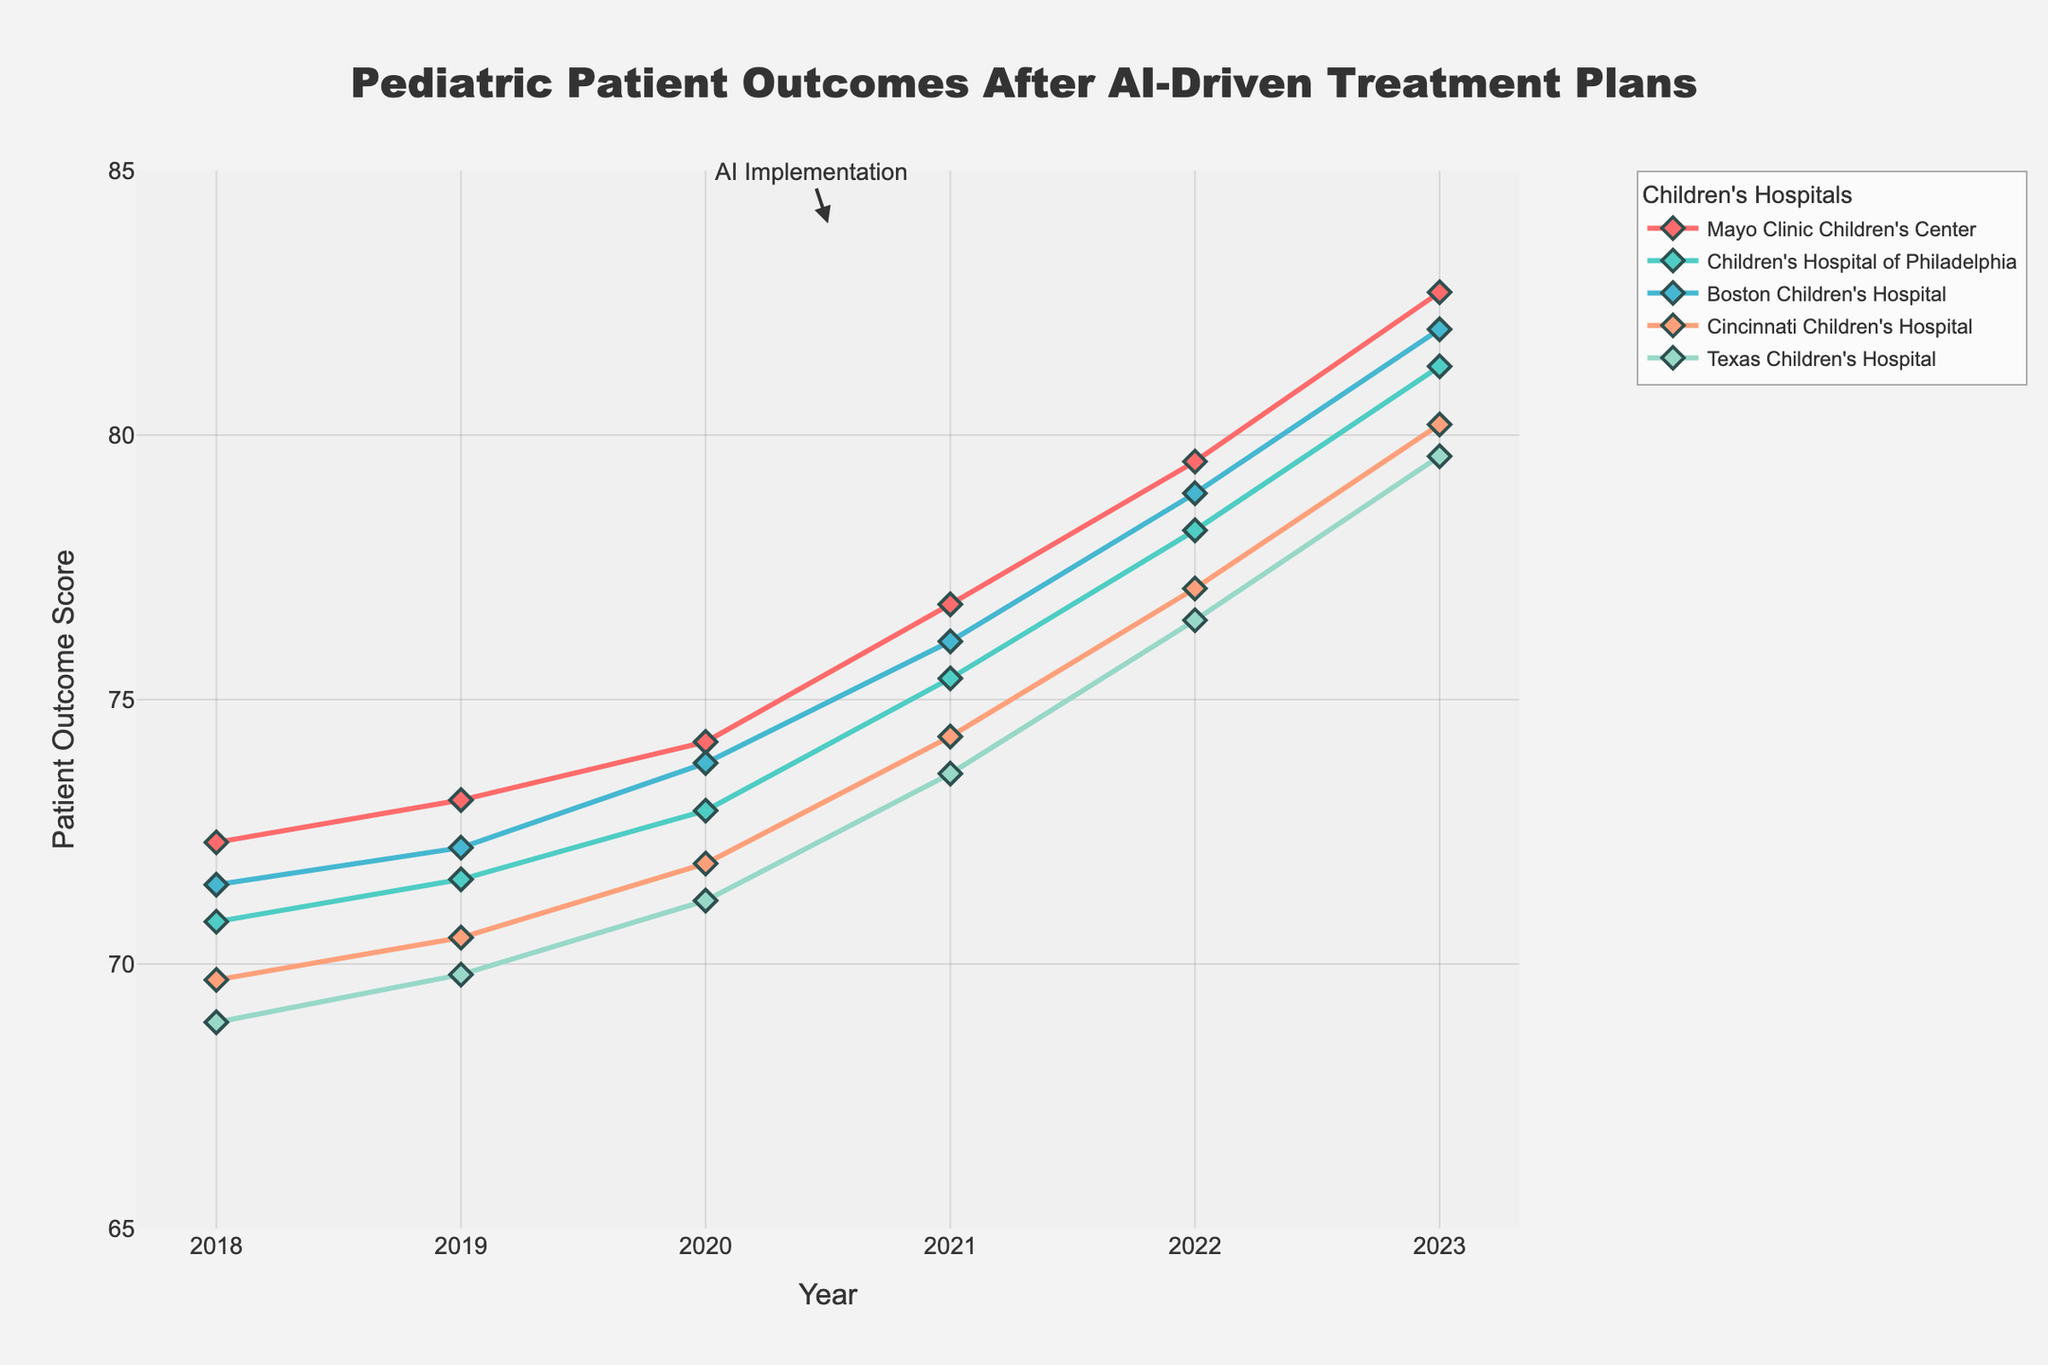What is the overall trend in patient outcome scores from 2018 to 2023 for the hospitals? A step-by-step review of the lines in the plot shows an overall increase in patient outcome scores for all the hospitals. Each line rises year by year until 2023, indicating an improvement.
Answer: Increasing Which hospital had the highest patient outcome score in 2023? By looking at the end of each line in the plot for 2023, the Mayo Clinic Children's Center has the highest outcome score (82.7).
Answer: Mayo Clinic Children's Center In what year did Boston Children's Hospital surpass a patient outcome score of 75? By tracing the line for Boston Children's Hospital, we see that it surpasses 75 in the year 2021.
Answer: 2021 By how many points did Cincinnati Children's Hospital's patient outcome scores increase from 2018 to 2023? To find the increase, subtract the score in 2018 (69.7) from the score in 2023 (80.2). The difference is 80.2 - 69.7 = 10.5 points.
Answer: 10.5 Which hospital showed the greatest improvement in patient outcome scores from 2020 to 2023? By calculating the difference for each hospital between 2020 and 2023 and comparing them, Mayo Clinic Children's Center improved from 74.2 to 82.7, which is an increase of 82.7 - 74.2 = 8.5 points, the largest improvement among the hospitals.
Answer: Mayo Clinic Children's Center How does the trend in patient outcomes for Texas Children's Hospital compare to that of Children's Hospital of Philadelphia from 2018 to 2023? Comparing the lines, both hospitals show an increasing trend. Texas Children's Hospital starts lower but maintains a steady rise similar to Children's Hospital of Philadelphia. Both follow a pattern of improvement, but Children's Hospital of Philadelphia remains constantly higher than Texas Children's Hospital over the years.
Answer: Both increasing, but Children's Hospital of Philadelphia consistently higher What was the average patient outcome score across all hospitals in 2022? By summing the scores for 2022 (79.5, 78.2, 78.9, 77.1, 76.5) and dividing by the number of hospitals (5), the average score is (79.5 + 78.2 + 78.9 + 77.1 + 76.5) / 5 = 78.04.
Answer: 78.04 By how many points did Mayo Clinic Children's Center's patient outcome score increase between 2021 and 2023? To find the increase, subtract the score in 2021 (76.8) from the score in 2023 (82.7). The difference is 82.7 - 76.8 = 5.9 points.
Answer: 5.9 